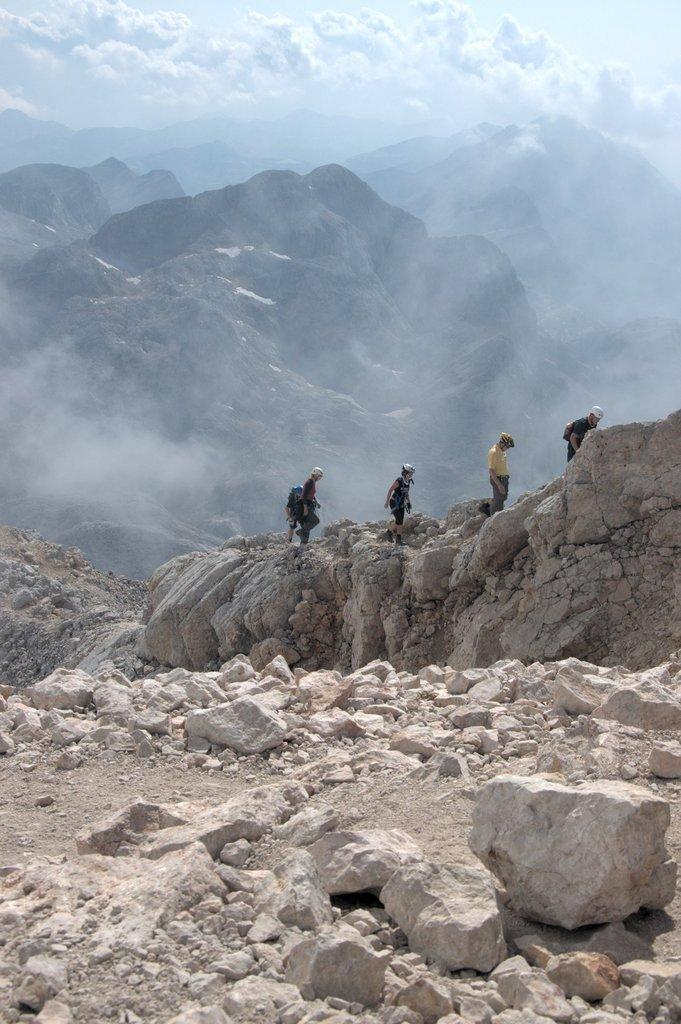What is located at the bottom of the image? There are stones at the bottom of the image. What type of natural formation can be seen in the image? There are mountains in the image. What is in the middle of the image? There is a group of people in the middle of the image. What can be seen in the background of the image? The sky is visible in the background of the image. What type of cloth is being used to grow corn in the image? There is no cloth or corn present in the image. What is the base material of the mountains in the image? The mountains in the image are made of natural materials like rock and soil, not a base material like cloth. 